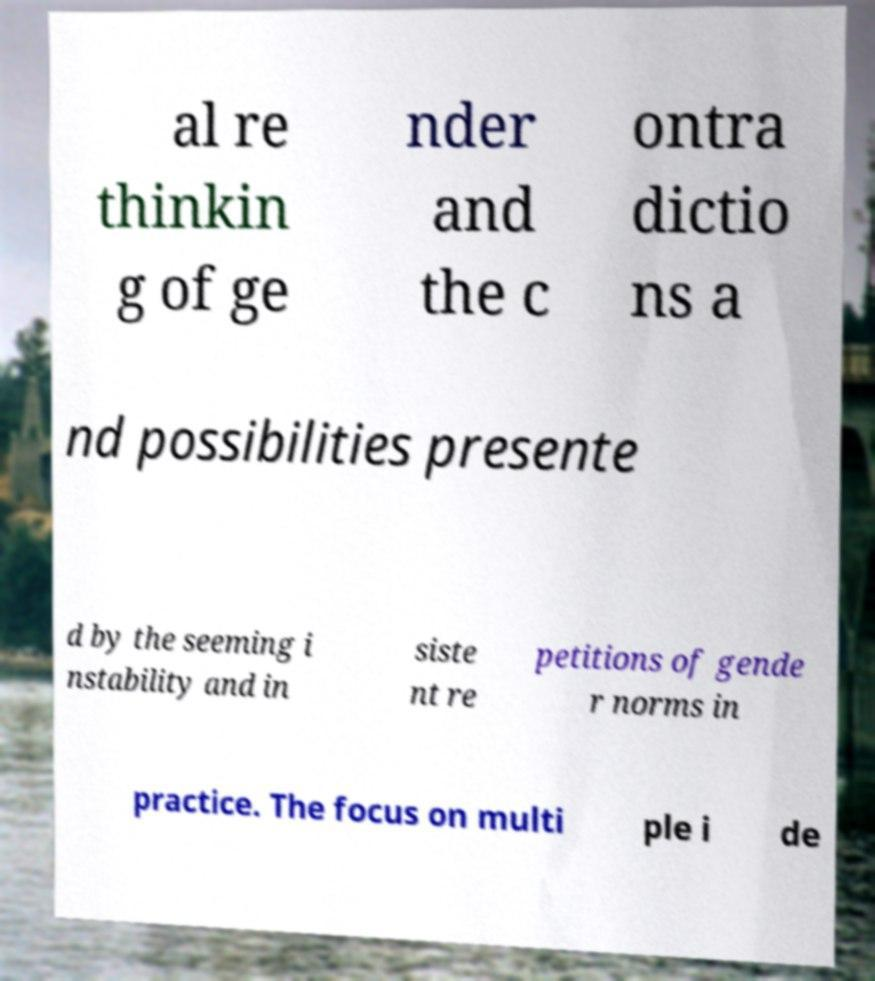Could you assist in decoding the text presented in this image and type it out clearly? al re thinkin g of ge nder and the c ontra dictio ns a nd possibilities presente d by the seeming i nstability and in siste nt re petitions of gende r norms in practice. The focus on multi ple i de 